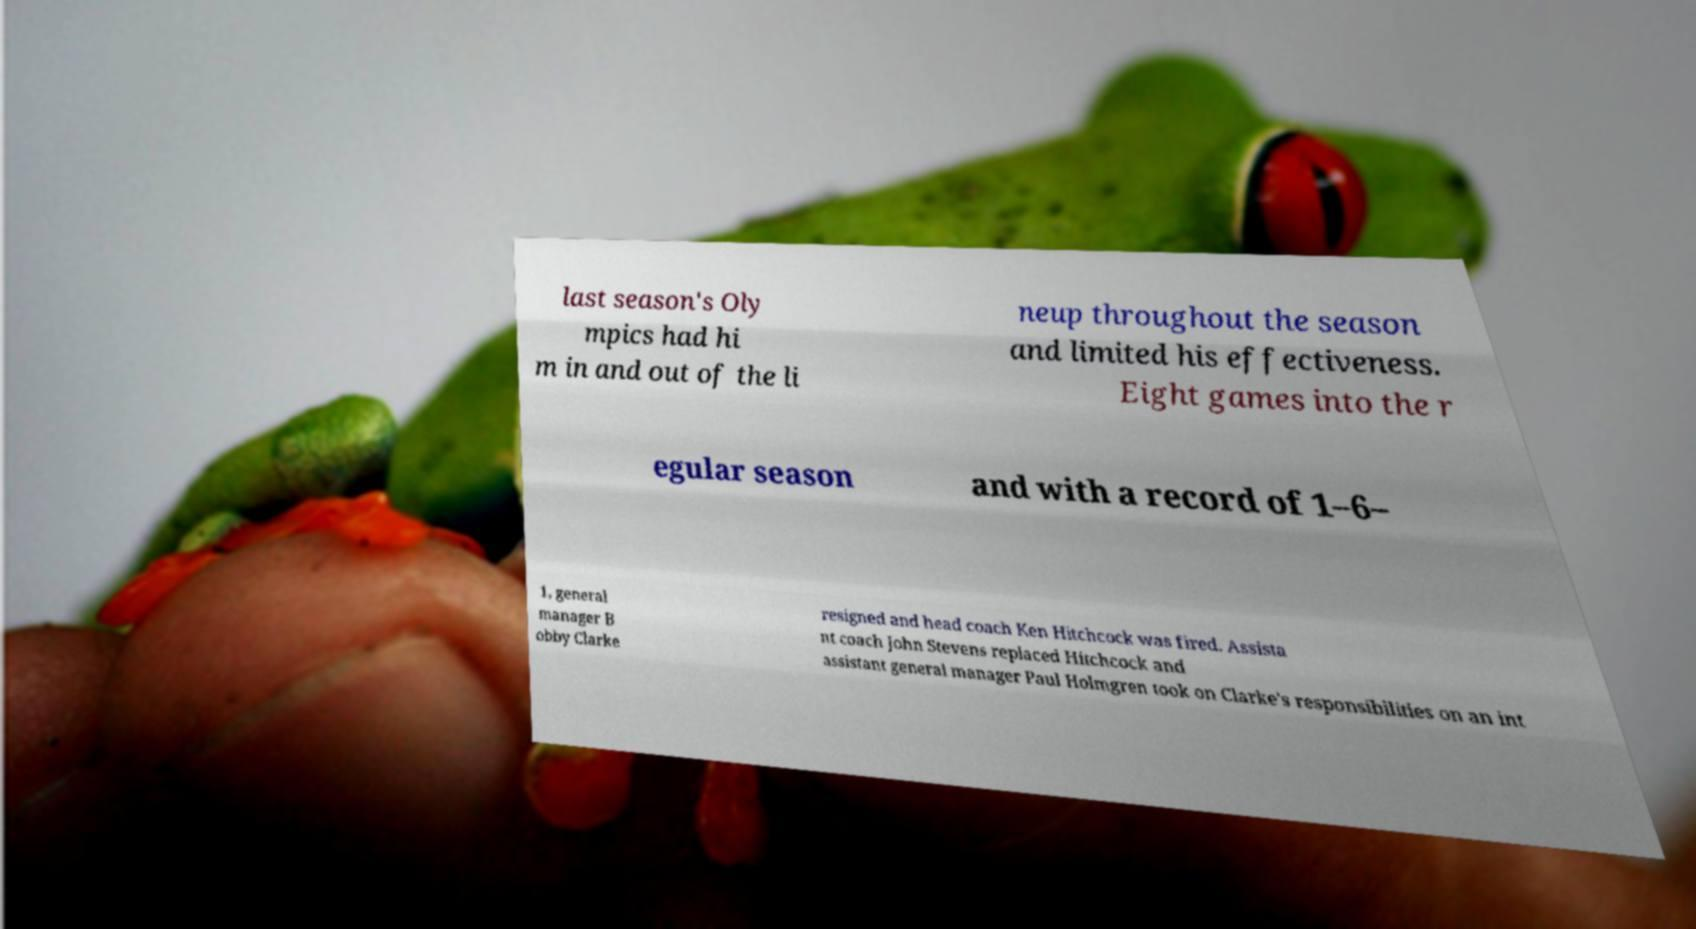What messages or text are displayed in this image? I need them in a readable, typed format. last season's Oly mpics had hi m in and out of the li neup throughout the season and limited his effectiveness. Eight games into the r egular season and with a record of 1–6– 1, general manager B obby Clarke resigned and head coach Ken Hitchcock was fired. Assista nt coach John Stevens replaced Hitchcock and assistant general manager Paul Holmgren took on Clarke's responsibilities on an int 